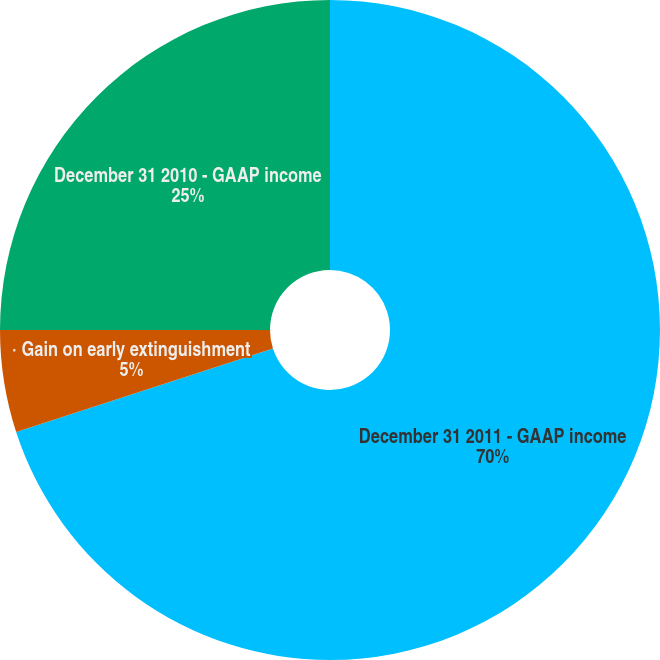<chart> <loc_0><loc_0><loc_500><loc_500><pie_chart><fcel>December 31 2011 - GAAP income<fcel>· Gain on early extinguishment<fcel>December 31 2010 - GAAP income<nl><fcel>70.0%<fcel>5.0%<fcel>25.0%<nl></chart> 